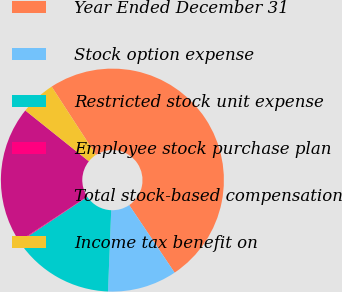Convert chart. <chart><loc_0><loc_0><loc_500><loc_500><pie_chart><fcel>Year Ended December 31<fcel>Stock option expense<fcel>Restricted stock unit expense<fcel>Employee stock purchase plan<fcel>Total stock-based compensation<fcel>Income tax benefit on<nl><fcel>49.75%<fcel>10.05%<fcel>15.01%<fcel>0.12%<fcel>19.98%<fcel>5.09%<nl></chart> 